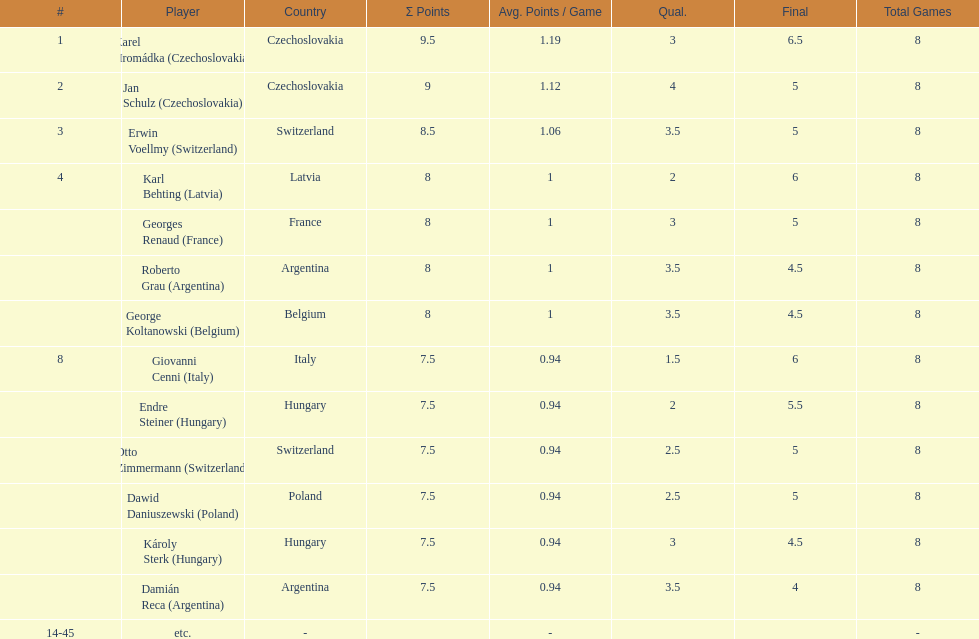How many players had final scores higher than 5? 4. Could you parse the entire table as a dict? {'header': ['#', 'Player', 'Country', 'Σ Points', 'Avg. Points / Game', 'Qual.', 'Final', 'Total Games'], 'rows': [['1', 'Karel Hromádka\xa0(Czechoslovakia)', 'Czechoslovakia', '9.5', '1.19', '3', '6.5', '8'], ['2', 'Jan Schulz\xa0(Czechoslovakia)', 'Czechoslovakia', '9', '1.12', '4', '5', '8'], ['3', 'Erwin Voellmy\xa0(Switzerland)', 'Switzerland', '8.5', '1.06', '3.5', '5', '8'], ['4', 'Karl Behting\xa0(Latvia)', 'Latvia', '8', '1', '2', '6', '8'], ['', 'Georges Renaud\xa0(France)', 'France', '8', '1', '3', '5', '8'], ['', 'Roberto Grau\xa0(Argentina)', 'Argentina', '8', '1', '3.5', '4.5', '8'], ['', 'George Koltanowski\xa0(Belgium)', 'Belgium', '8', '1', '3.5', '4.5', '8'], ['8', 'Giovanni Cenni\xa0(Italy)', 'Italy', '7.5', '0.94', '1.5', '6', '8'], ['', 'Endre Steiner\xa0(Hungary)', 'Hungary', '7.5', '0.94', '2', '5.5', '8'], ['', 'Otto Zimmermann\xa0(Switzerland)', 'Switzerland', '7.5', '0.94', '2.5', '5', '8'], ['', 'Dawid Daniuszewski\xa0(Poland)', 'Poland', '7.5', '0.94', '2.5', '5', '8'], ['', 'Károly Sterk\xa0(Hungary)', 'Hungary', '7.5', '0.94', '3', '4.5', '8'], ['', 'Damián Reca\xa0(Argentina)', 'Argentina', '7.5', '0.94', '3.5', '4', '8'], ['14-45', 'etc.', '-', '', '-', '', '', '-']]} 